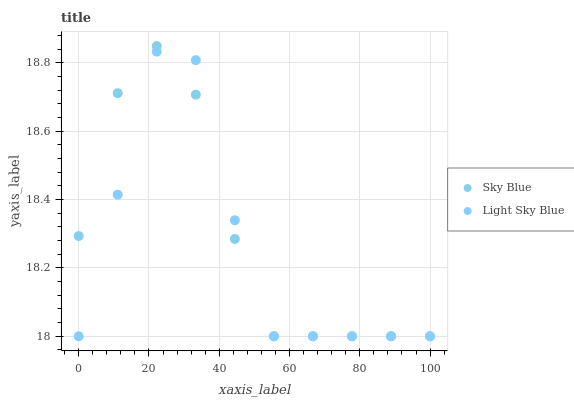Does Light Sky Blue have the minimum area under the curve?
Answer yes or no. Yes. Does Sky Blue have the maximum area under the curve?
Answer yes or no. Yes. Does Light Sky Blue have the maximum area under the curve?
Answer yes or no. No. Is Sky Blue the smoothest?
Answer yes or no. Yes. Is Light Sky Blue the roughest?
Answer yes or no. Yes. Is Light Sky Blue the smoothest?
Answer yes or no. No. Does Sky Blue have the lowest value?
Answer yes or no. Yes. Does Sky Blue have the highest value?
Answer yes or no. Yes. Does Light Sky Blue have the highest value?
Answer yes or no. No. Does Light Sky Blue intersect Sky Blue?
Answer yes or no. Yes. Is Light Sky Blue less than Sky Blue?
Answer yes or no. No. Is Light Sky Blue greater than Sky Blue?
Answer yes or no. No. 